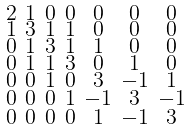<formula> <loc_0><loc_0><loc_500><loc_500>\begin{smallmatrix} 2 & 1 & 0 & 0 & 0 & 0 & 0 \\ 1 & 3 & 1 & 1 & 0 & 0 & 0 \\ 0 & 1 & 3 & 1 & 1 & 0 & 0 \\ 0 & 1 & 1 & 3 & 0 & 1 & 0 \\ 0 & 0 & 1 & 0 & 3 & - 1 & 1 \\ 0 & 0 & 0 & 1 & - 1 & 3 & - 1 \\ 0 & 0 & 0 & 0 & 1 & - 1 & 3 \end{smallmatrix}</formula> 